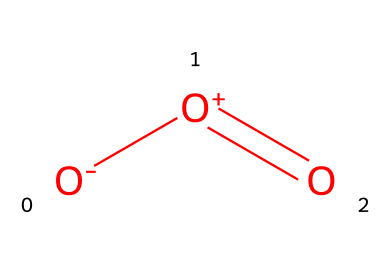What is the molecular formula of this chemical? The chemical structure contains three oxygen atoms indicated by the three 'O's present in the SMILES representation. Hence, the molecular formula consists of three oxygen atoms.
Answer: O3 How many bonds are present in this chemical? In the structure, there is one double bond between two oxygen atoms and a single bond with the third oxygen. Therefore, there are two bonds in total.
Answer: 2 What type of gas is represented by this chemical? The structure indicates that this chemical is ozone, which is recognized as a triatomic form of oxygen. Therefore, it is classified as a gas.
Answer: gas What charge does the molecule have? The SMILES representation shows an oxygen atom with a negative charge '[O-]' and another with a positive charge '[O+]'. Thus, the overall charge of the molecule is neutral due to balancing charges.
Answer: neutral Is this chemical a pollutant? Ozone is known for its role in contributing to air pollution when present at ground level, making it a significant environmental issue.
Answer: yes What is the primary role of this gas in the atmosphere? This gas primarily functions in absorbing ultraviolet radiation from the sun, protecting living organisms from its harmful effects.
Answer: protection 